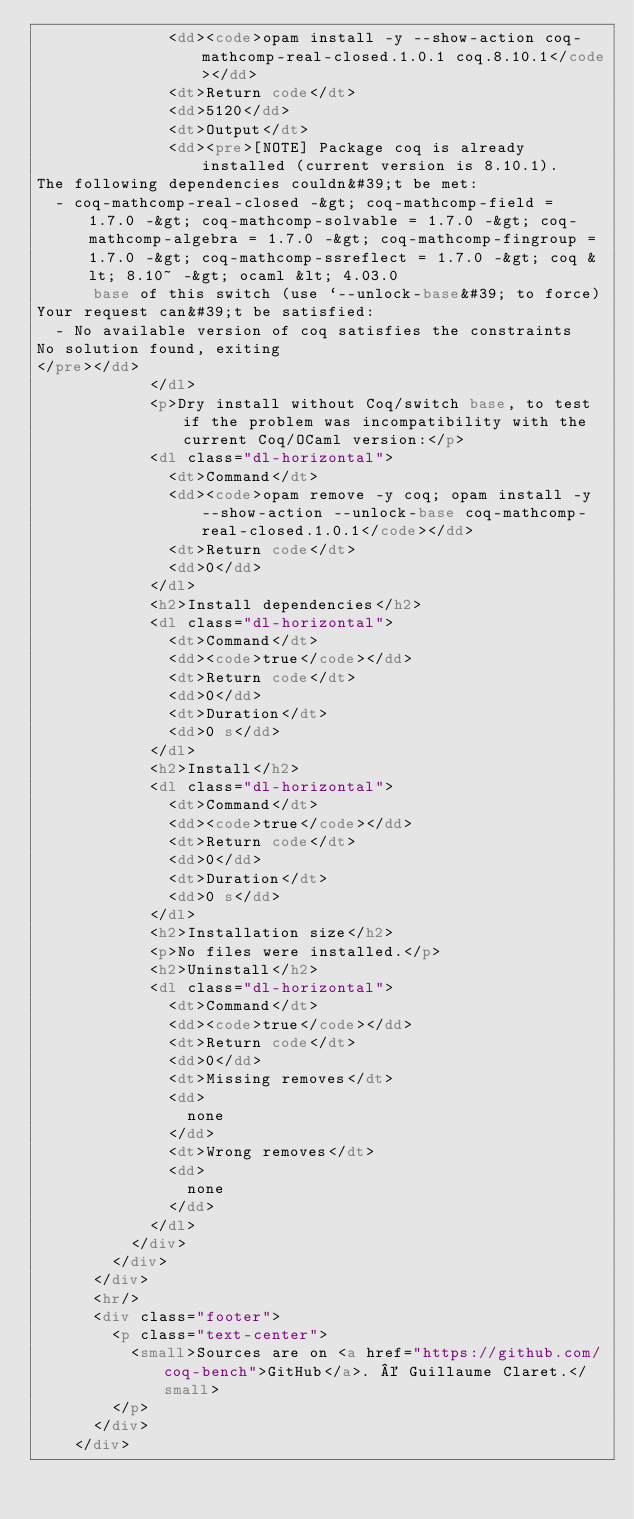<code> <loc_0><loc_0><loc_500><loc_500><_HTML_>              <dd><code>opam install -y --show-action coq-mathcomp-real-closed.1.0.1 coq.8.10.1</code></dd>
              <dt>Return code</dt>
              <dd>5120</dd>
              <dt>Output</dt>
              <dd><pre>[NOTE] Package coq is already installed (current version is 8.10.1).
The following dependencies couldn&#39;t be met:
  - coq-mathcomp-real-closed -&gt; coq-mathcomp-field = 1.7.0 -&gt; coq-mathcomp-solvable = 1.7.0 -&gt; coq-mathcomp-algebra = 1.7.0 -&gt; coq-mathcomp-fingroup = 1.7.0 -&gt; coq-mathcomp-ssreflect = 1.7.0 -&gt; coq &lt; 8.10~ -&gt; ocaml &lt; 4.03.0
      base of this switch (use `--unlock-base&#39; to force)
Your request can&#39;t be satisfied:
  - No available version of coq satisfies the constraints
No solution found, exiting
</pre></dd>
            </dl>
            <p>Dry install without Coq/switch base, to test if the problem was incompatibility with the current Coq/OCaml version:</p>
            <dl class="dl-horizontal">
              <dt>Command</dt>
              <dd><code>opam remove -y coq; opam install -y --show-action --unlock-base coq-mathcomp-real-closed.1.0.1</code></dd>
              <dt>Return code</dt>
              <dd>0</dd>
            </dl>
            <h2>Install dependencies</h2>
            <dl class="dl-horizontal">
              <dt>Command</dt>
              <dd><code>true</code></dd>
              <dt>Return code</dt>
              <dd>0</dd>
              <dt>Duration</dt>
              <dd>0 s</dd>
            </dl>
            <h2>Install</h2>
            <dl class="dl-horizontal">
              <dt>Command</dt>
              <dd><code>true</code></dd>
              <dt>Return code</dt>
              <dd>0</dd>
              <dt>Duration</dt>
              <dd>0 s</dd>
            </dl>
            <h2>Installation size</h2>
            <p>No files were installed.</p>
            <h2>Uninstall</h2>
            <dl class="dl-horizontal">
              <dt>Command</dt>
              <dd><code>true</code></dd>
              <dt>Return code</dt>
              <dd>0</dd>
              <dt>Missing removes</dt>
              <dd>
                none
              </dd>
              <dt>Wrong removes</dt>
              <dd>
                none
              </dd>
            </dl>
          </div>
        </div>
      </div>
      <hr/>
      <div class="footer">
        <p class="text-center">
          <small>Sources are on <a href="https://github.com/coq-bench">GitHub</a>. © Guillaume Claret.</small>
        </p>
      </div>
    </div></code> 